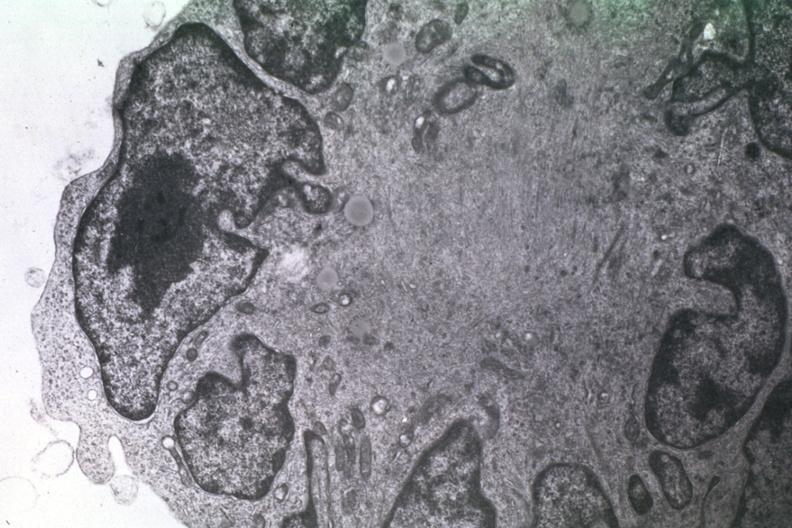what is present?
Answer the question using a single word or phrase. Brain 